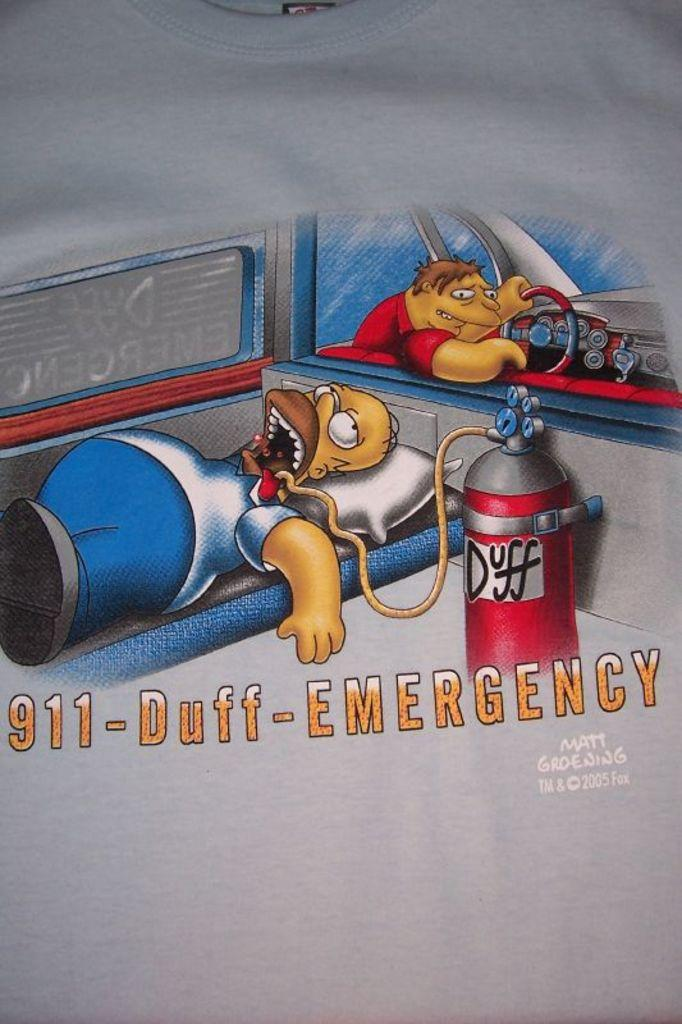<image>
Write a terse but informative summary of the picture. An illustration of Homer Simpson shows him in the back of an ambulance with an IV of Duff beer. 